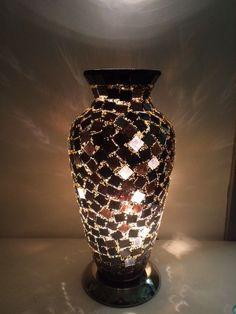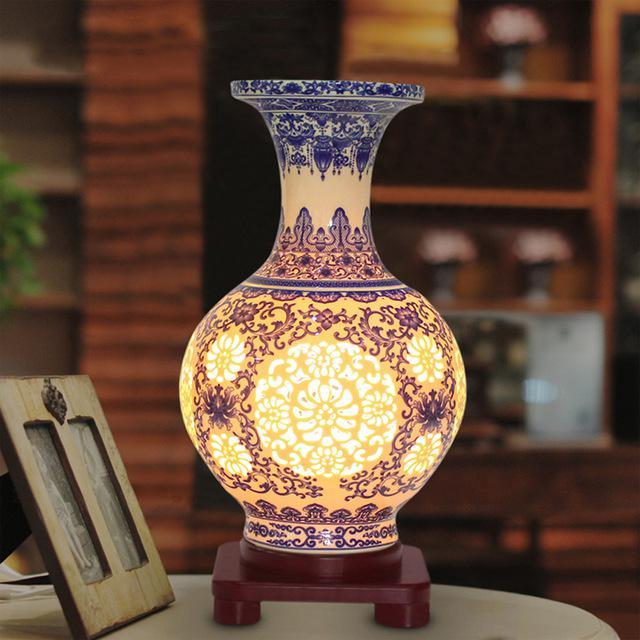The first image is the image on the left, the second image is the image on the right. Assess this claim about the two images: "One vase has a narrow neck, a footed base, and a circular design on the front, and it is seen head-on.". Correct or not? Answer yes or no. Yes. The first image is the image on the left, the second image is the image on the right. For the images shown, is this caption "A glowing vase is sitting on a wood-like stand with at least two short legs." true? Answer yes or no. Yes. 